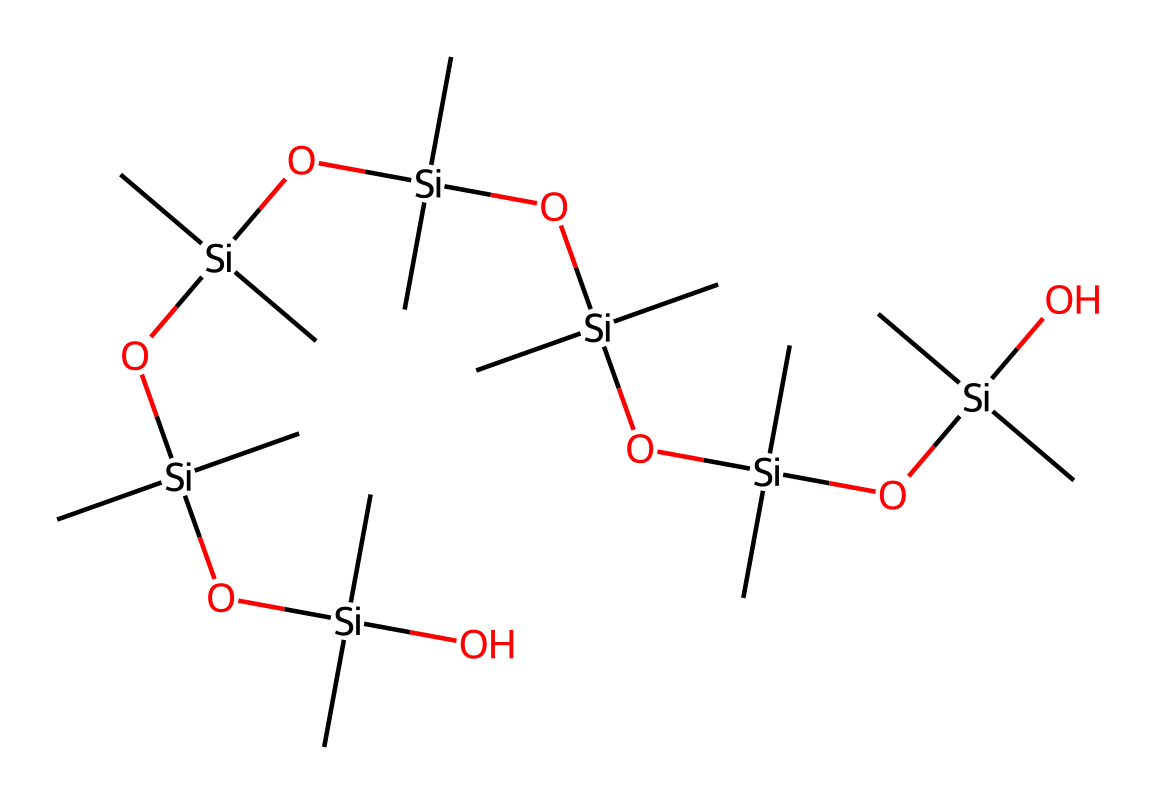what is the primary element in this chemical structure? The chemical structure includes silicon, which is clearly denoted by the presence of the Si symbol multiple times throughout the SMILES representation.
Answer: silicon how many silicon atoms are present in this structure? By analyzing the SMILES representation, we can count each instance of the Si symbol; there are a total of 8 silicon atoms visible.
Answer: 8 what is the total number of oxygen atoms in this chemical? Each occurrence of the O symbol represents an oxygen atom. Scanning through the SMILES, we find there are a total of 6 oxygen atoms present.
Answer: 6 how many methyl groups are attached to the silicon atoms? In the SMILES representation, each (C) indicates a methyl group attached to the silicon atoms. Counting these gives us 12 methyl groups in total.
Answer: 12 what type of chemical bonding is predominantly found in silicone sealants? The presence of silicon-oxygen (Si-O) bonds is essential in this chemical structure, which characterizes the typical framework of silicone polymers like silicone sealants.
Answer: silicon-oxygen which properties of silicone sealants are attributed to this chemical structure? The combination of silicon, oxygen, and organic groups results in properties such as flexibility and resistance to moisture, which are vital for the performance of silicone sealants in construction applications.
Answer: flexibility and moisture resistance what role do the silicon atoms play in the sealant’s performance? The silicon atoms provide structural stability and enhance the sealant's resistance to temperature fluctuations and chemical exposure, crucial for infrastructure longevity.
Answer: structural stability and chemical resistance 